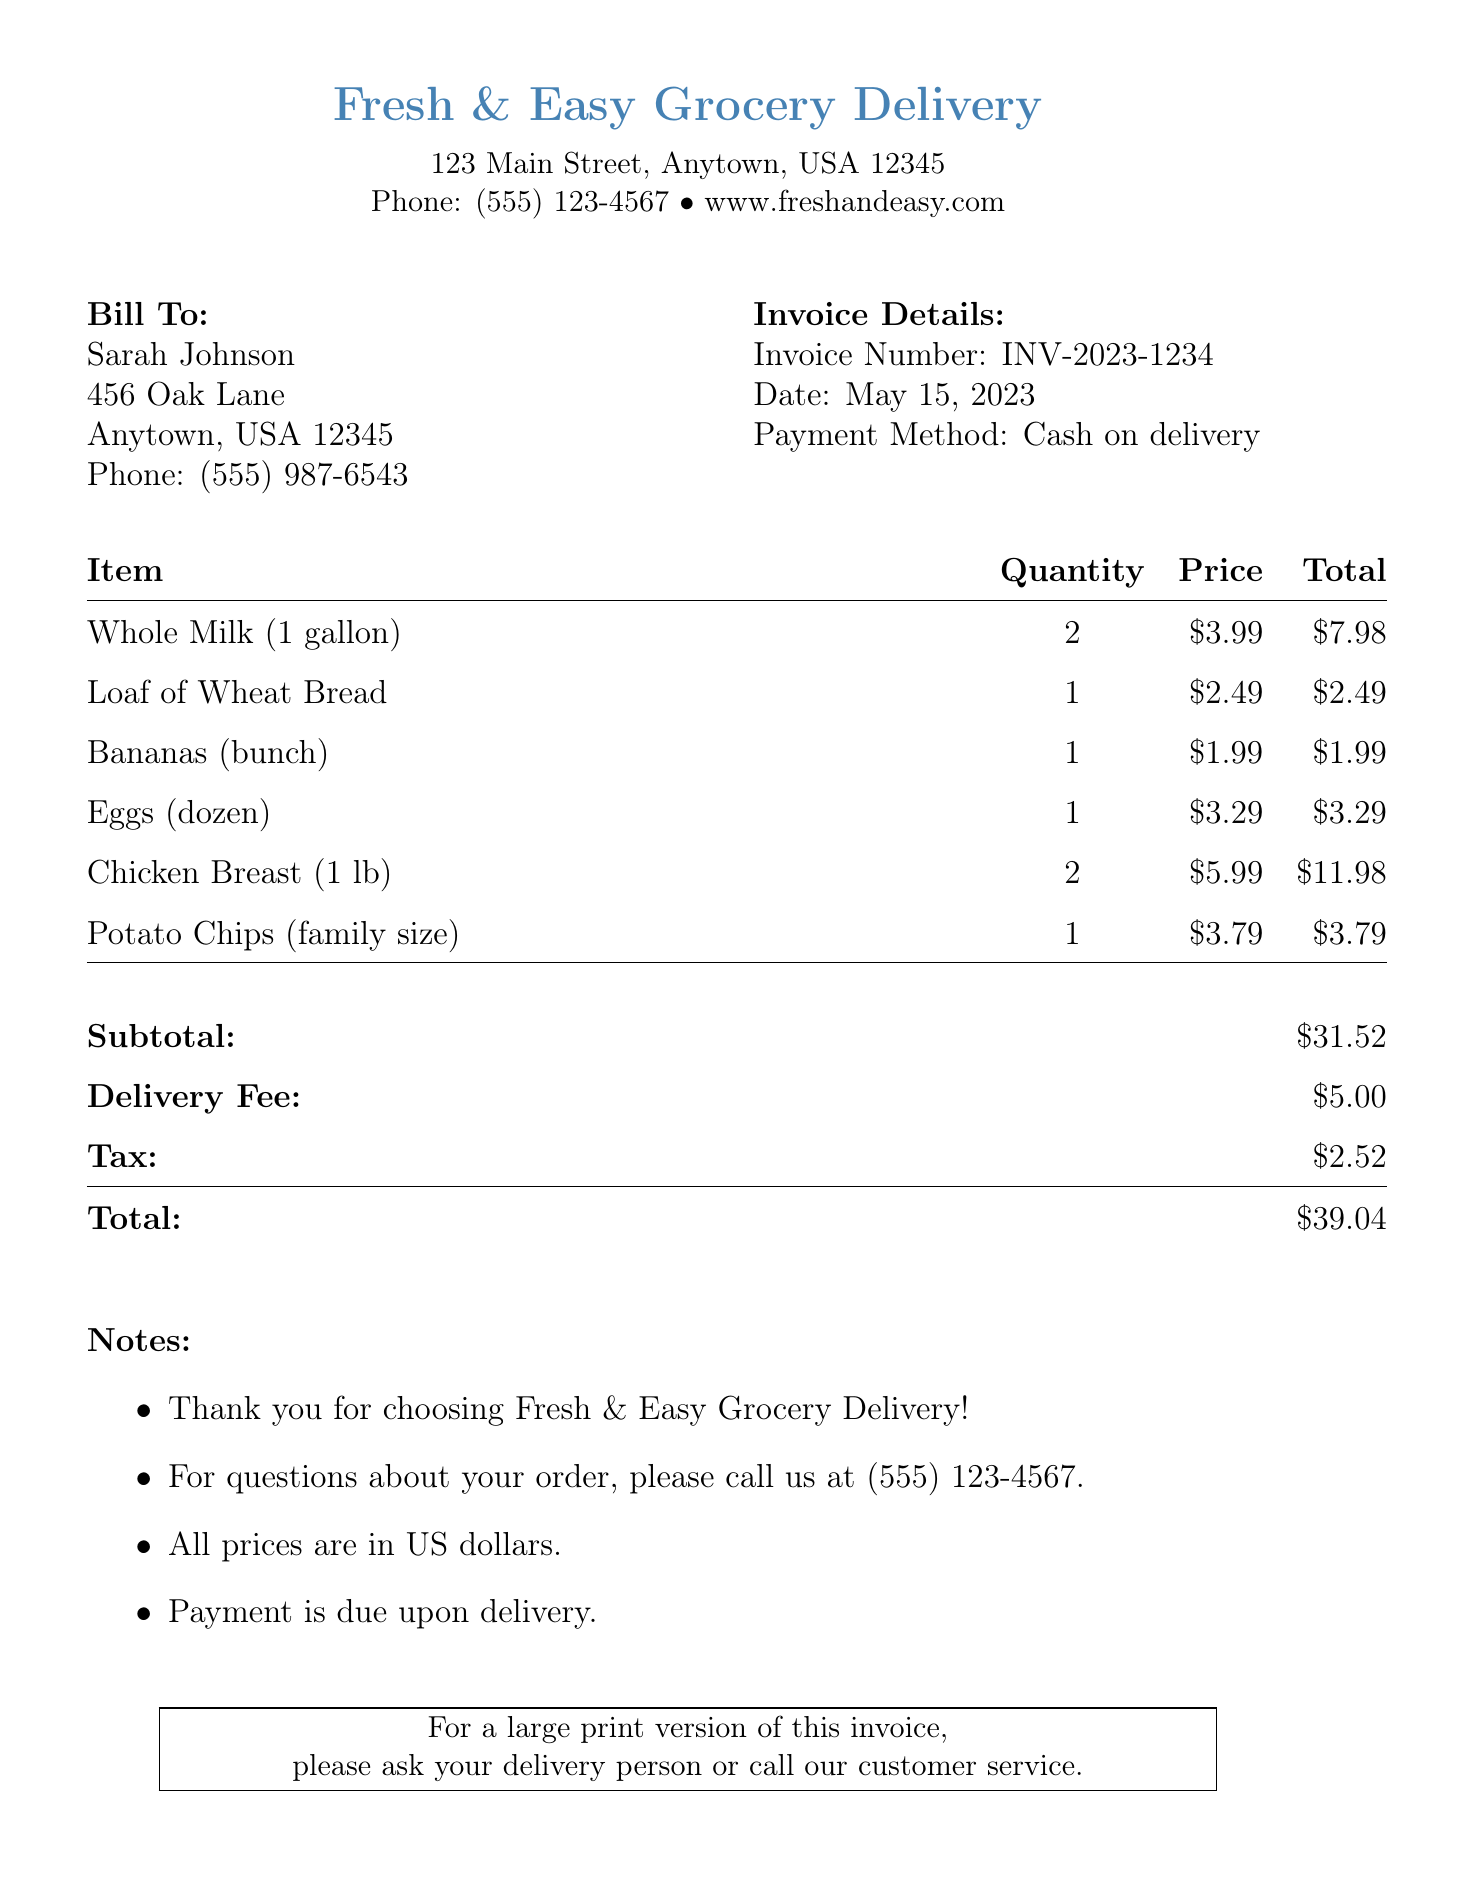What is the name of the grocery delivery service? The name of the grocery delivery service can be found in the header of the invoice.
Answer: Fresh & Easy Grocery Delivery What is the invoice number? The invoice number is listed in the invoice details section.
Answer: INV-2023-1234 What is the total amount due? The total amount due is shown at the bottom of the invoice totals section.
Answer: $39.04 What is the delivery fee? The delivery fee is specified in the totals section of the invoice.
Answer: $5.00 How many gallons of whole milk were purchased? The quantity of whole milk is indicated in the items list.
Answer: 2 What date was the invoice issued? The date can be found in the invoice details section.
Answer: May 15, 2023 What payment method is used? The payment method is outlined in the invoice details section.
Answer: Cash on delivery Who is the customer? The customer's name is displayed in the bill to section of the invoice.
Answer: Sarah Johnson What is stated about large print invoices? The information about large print invoices is located at the end of the document.
Answer: Ask your delivery person or call our customer service 